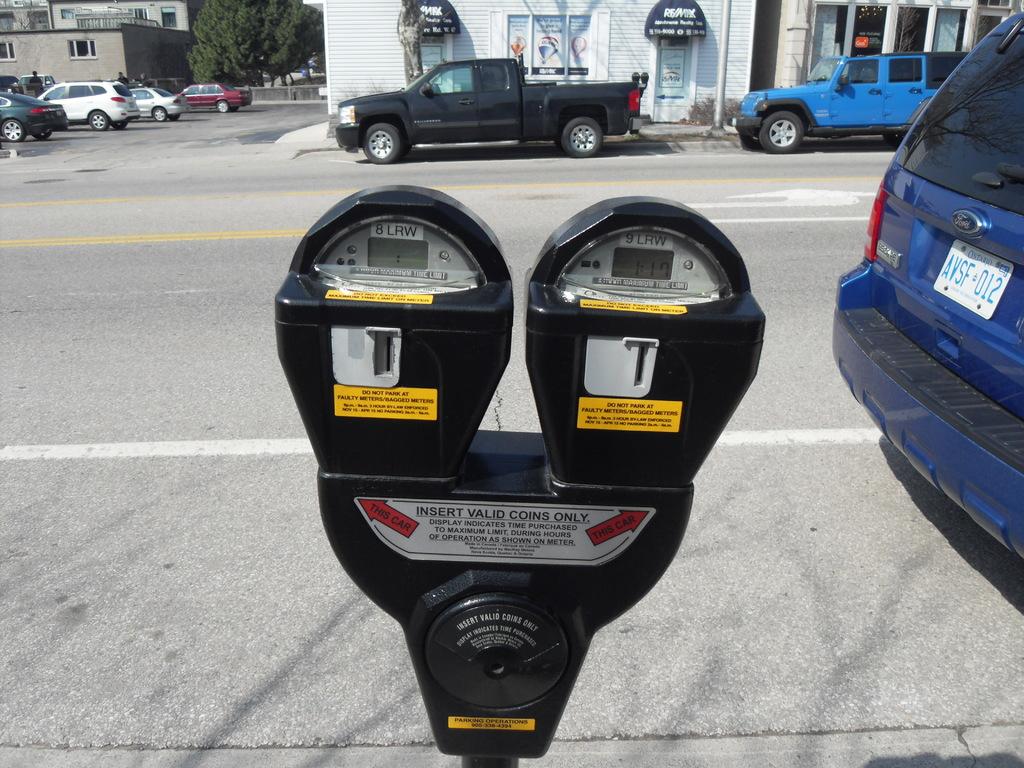What kind of coin do you insert?
Offer a very short reply. Valid. What is the license plate number on the blue vehicle?
Your response must be concise. Avsf 012. 